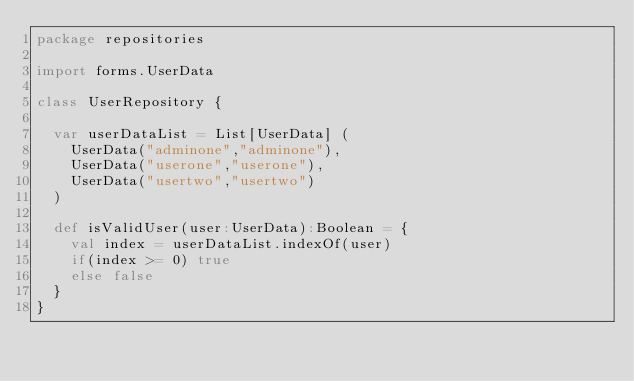Convert code to text. <code><loc_0><loc_0><loc_500><loc_500><_Scala_>package repositories

import forms.UserData

class UserRepository {

  var userDataList = List[UserData] (
    UserData("adminone","adminone"),
    UserData("userone","userone"),
    UserData("usertwo","usertwo")
  )

  def isValidUser(user:UserData):Boolean = {
    val index = userDataList.indexOf(user)
    if(index >= 0) true
    else false
  }
}
</code> 